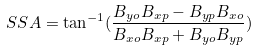<formula> <loc_0><loc_0><loc_500><loc_500>S S A = \tan ^ { - 1 } ( \frac { B _ { y o } B _ { x p } - B _ { y p } B _ { x o } } { B _ { x o } B _ { x p } + B _ { y o } B _ { y p } } )</formula> 